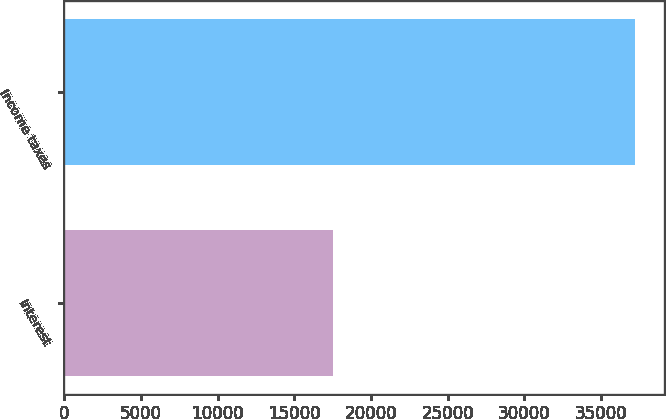Convert chart to OTSL. <chart><loc_0><loc_0><loc_500><loc_500><bar_chart><fcel>Interest<fcel>Income taxes<nl><fcel>17541<fcel>37222<nl></chart> 